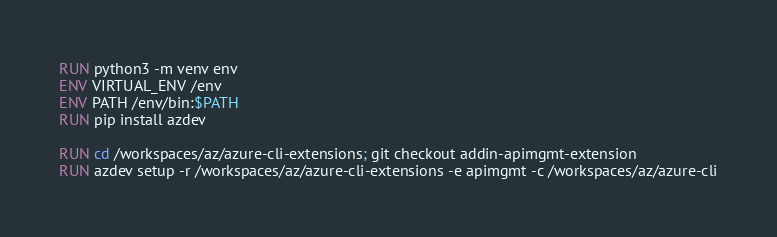Convert code to text. <code><loc_0><loc_0><loc_500><loc_500><_Dockerfile_>RUN python3 -m venv env
ENV VIRTUAL_ENV /env
ENV PATH /env/bin:$PATH
RUN pip install azdev

RUN cd /workspaces/az/azure-cli-extensions; git checkout addin-apimgmt-extension
RUN azdev setup -r /workspaces/az/azure-cli-extensions -e apimgmt -c /workspaces/az/azure-cli
</code> 